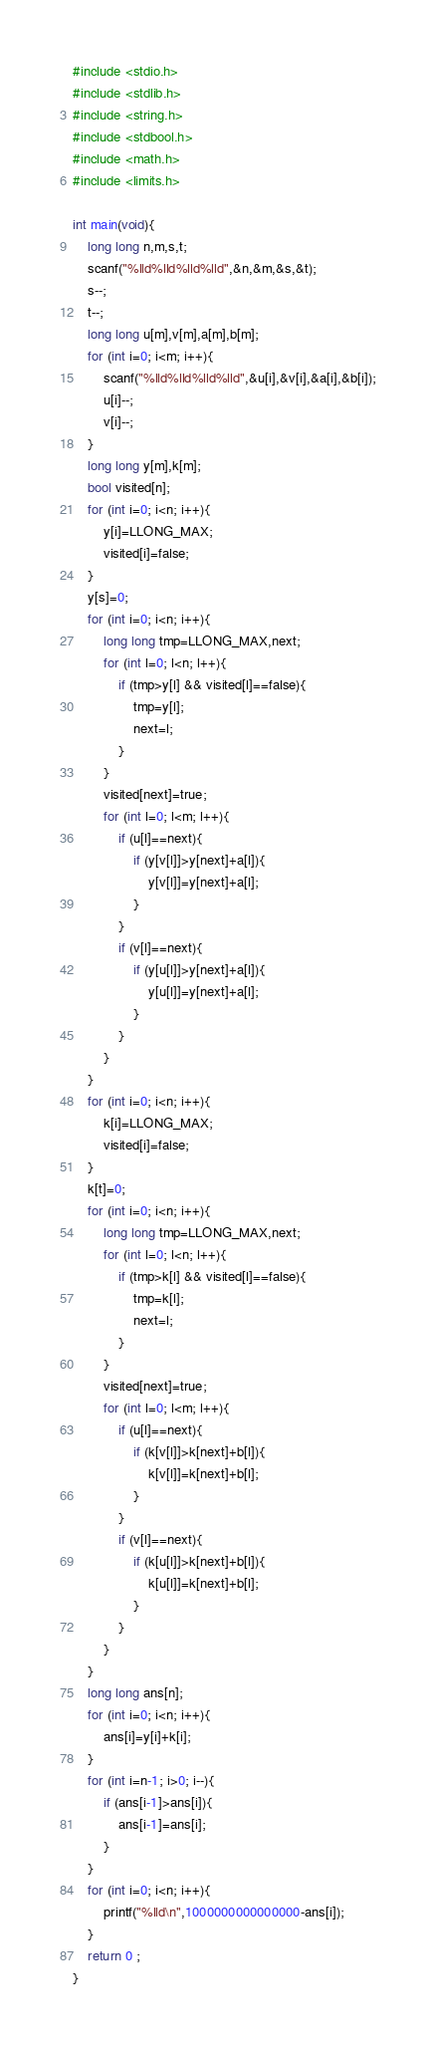<code> <loc_0><loc_0><loc_500><loc_500><_C_>#include <stdio.h>
#include <stdlib.h>
#include <string.h>
#include <stdbool.h>
#include <math.h>
#include <limits.h>

int main(void){
    long long n,m,s,t;
    scanf("%lld%lld%lld%lld",&n,&m,&s,&t);
    s--;
    t--;
    long long u[m],v[m],a[m],b[m];
    for (int i=0; i<m; i++){
        scanf("%lld%lld%lld%lld",&u[i],&v[i],&a[i],&b[i]);
        u[i]--;
        v[i]--;
    }
    long long y[m],k[m];
    bool visited[n];
    for (int i=0; i<n; i++){
        y[i]=LLONG_MAX;
        visited[i]=false;
    }    
    y[s]=0;
    for (int i=0; i<n; i++){
        long long tmp=LLONG_MAX,next;
        for (int l=0; l<n; l++){
            if (tmp>y[l] && visited[l]==false){
                tmp=y[l];
                next=l;
            }
        }
        visited[next]=true;
        for (int l=0; l<m; l++){
            if (u[l]==next){
                if (y[v[l]]>y[next]+a[l]){
                    y[v[l]]=y[next]+a[l];
                }
            }
            if (v[l]==next){
                if (y[u[l]]>y[next]+a[l]){
                    y[u[l]]=y[next]+a[l];
                }
            }
        }
    }
    for (int i=0; i<n; i++){
        k[i]=LLONG_MAX;
        visited[i]=false;
    }    
    k[t]=0;
    for (int i=0; i<n; i++){
        long long tmp=LLONG_MAX,next;
        for (int l=0; l<n; l++){
            if (tmp>k[l] && visited[l]==false){
                tmp=k[l];
                next=l;
            }
        }
        visited[next]=true;
        for (int l=0; l<m; l++){
            if (u[l]==next){
                if (k[v[l]]>k[next]+b[l]){
                    k[v[l]]=k[next]+b[l];
                }
            }
            if (v[l]==next){
                if (k[u[l]]>k[next]+b[l]){
                    k[u[l]]=k[next]+b[l];
                }
            }
        }
    } 
    long long ans[n];
    for (int i=0; i<n; i++){
        ans[i]=y[i]+k[i];
    }
    for (int i=n-1; i>0; i--){
        if (ans[i-1]>ans[i]){
            ans[i-1]=ans[i];
        }
    }
    for (int i=0; i<n; i++){
        printf("%lld\n",1000000000000000-ans[i]);
    }
	return 0 ;
}</code> 